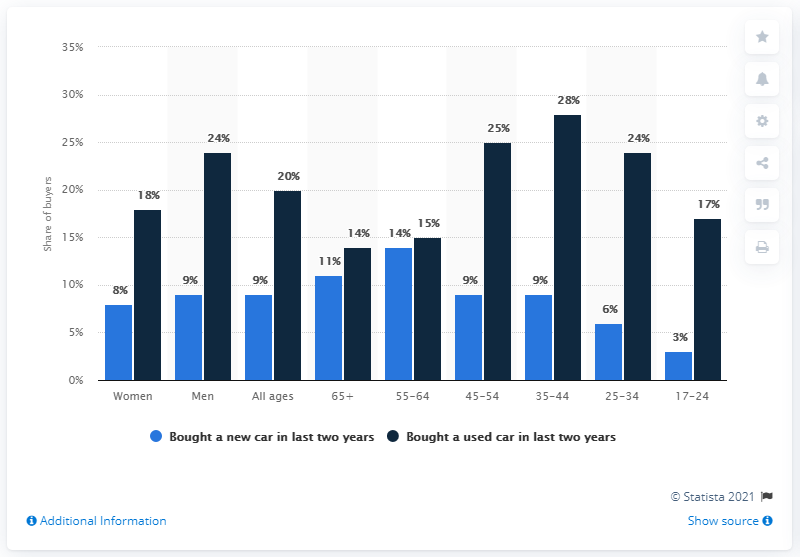Point out several critical features in this image. The age group with the smallest proportion of respondents who had bought a new car was 17-24 year olds. 